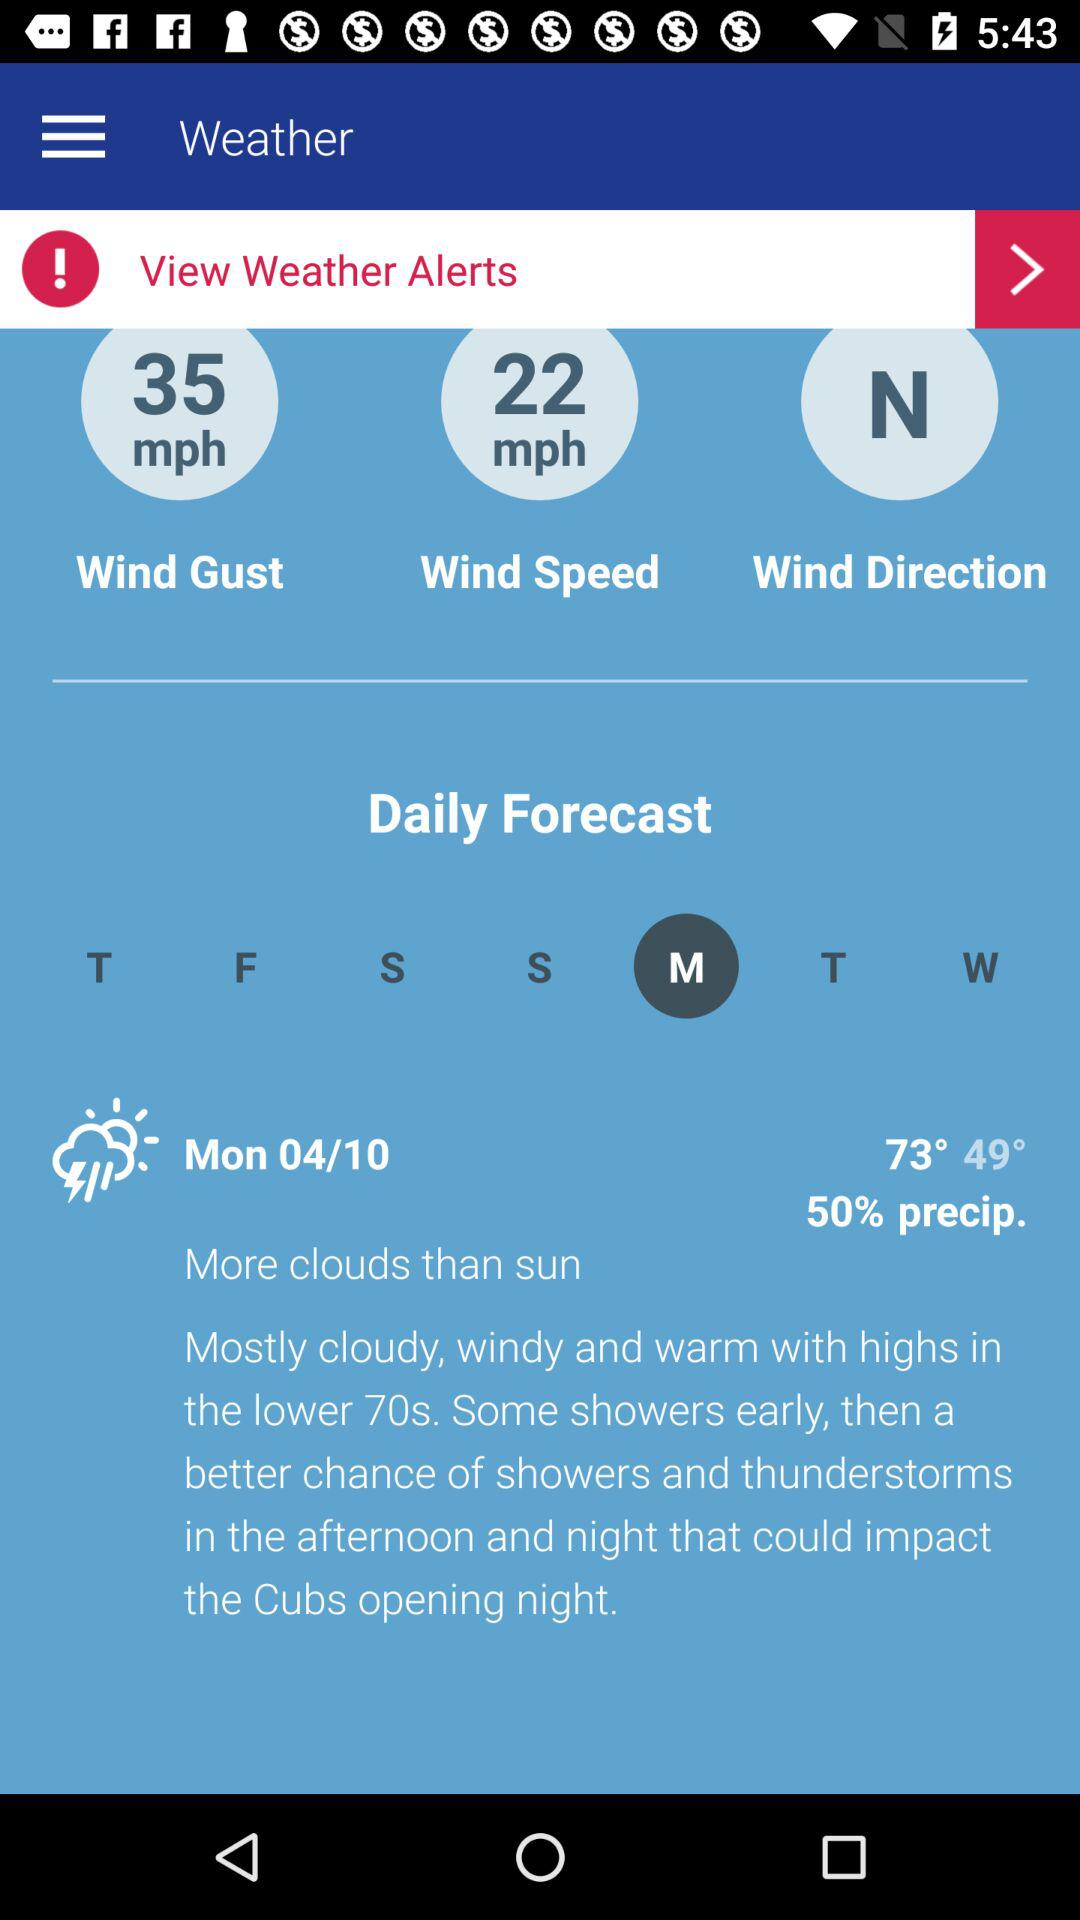Who issues the weather alerts?
When the provided information is insufficient, respond with <no answer>. <no answer> 